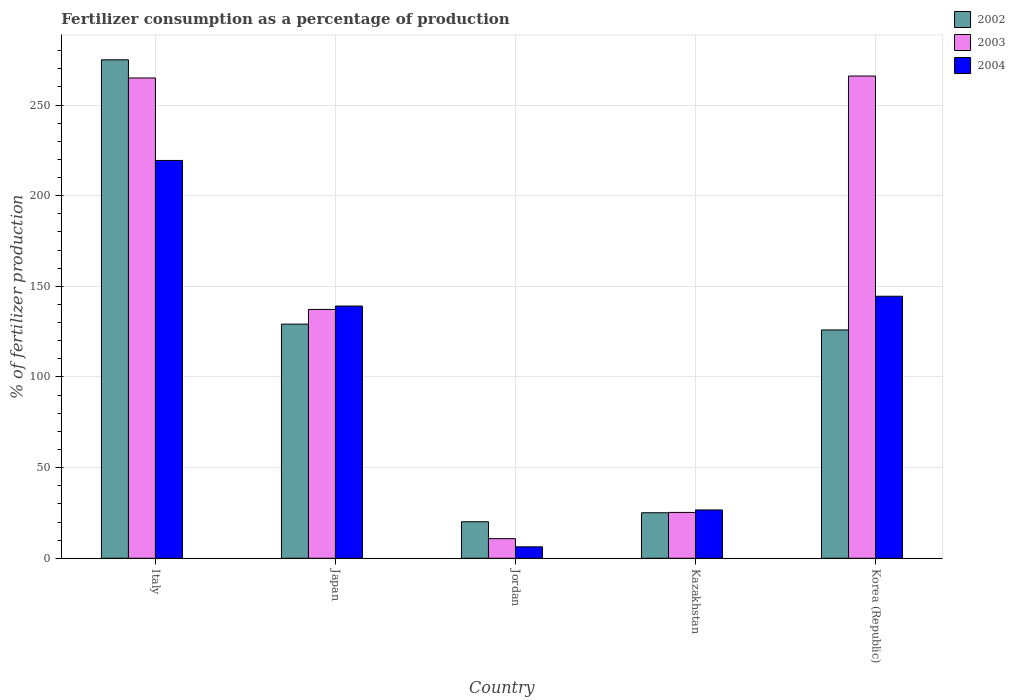Are the number of bars per tick equal to the number of legend labels?
Offer a terse response. Yes. Are the number of bars on each tick of the X-axis equal?
Your response must be concise. Yes. What is the label of the 3rd group of bars from the left?
Offer a very short reply. Jordan. What is the percentage of fertilizers consumed in 2004 in Korea (Republic)?
Your response must be concise. 144.54. Across all countries, what is the maximum percentage of fertilizers consumed in 2004?
Your response must be concise. 219.45. Across all countries, what is the minimum percentage of fertilizers consumed in 2003?
Offer a very short reply. 10.83. In which country was the percentage of fertilizers consumed in 2004 maximum?
Make the answer very short. Italy. In which country was the percentage of fertilizers consumed in 2004 minimum?
Provide a succinct answer. Jordan. What is the total percentage of fertilizers consumed in 2004 in the graph?
Give a very brief answer. 536.07. What is the difference between the percentage of fertilizers consumed in 2002 in Japan and that in Jordan?
Provide a succinct answer. 109.02. What is the difference between the percentage of fertilizers consumed in 2004 in Italy and the percentage of fertilizers consumed in 2002 in Jordan?
Offer a very short reply. 199.3. What is the average percentage of fertilizers consumed in 2003 per country?
Give a very brief answer. 140.87. What is the difference between the percentage of fertilizers consumed of/in 2004 and percentage of fertilizers consumed of/in 2002 in Korea (Republic)?
Your answer should be very brief. 18.59. In how many countries, is the percentage of fertilizers consumed in 2002 greater than 180 %?
Your answer should be compact. 1. What is the ratio of the percentage of fertilizers consumed in 2002 in Italy to that in Korea (Republic)?
Keep it short and to the point. 2.18. Is the difference between the percentage of fertilizers consumed in 2004 in Kazakhstan and Korea (Republic) greater than the difference between the percentage of fertilizers consumed in 2002 in Kazakhstan and Korea (Republic)?
Give a very brief answer. No. What is the difference between the highest and the second highest percentage of fertilizers consumed in 2002?
Keep it short and to the point. -145.81. What is the difference between the highest and the lowest percentage of fertilizers consumed in 2004?
Your response must be concise. 213.14. Is the sum of the percentage of fertilizers consumed in 2004 in Jordan and Korea (Republic) greater than the maximum percentage of fertilizers consumed in 2002 across all countries?
Make the answer very short. No. What does the 1st bar from the left in Korea (Republic) represents?
Make the answer very short. 2002. What does the 1st bar from the right in Korea (Republic) represents?
Ensure brevity in your answer.  2004. How many bars are there?
Offer a very short reply. 15. Are all the bars in the graph horizontal?
Give a very brief answer. No. How many countries are there in the graph?
Ensure brevity in your answer.  5. Are the values on the major ticks of Y-axis written in scientific E-notation?
Offer a very short reply. No. How many legend labels are there?
Give a very brief answer. 3. How are the legend labels stacked?
Offer a terse response. Vertical. What is the title of the graph?
Keep it short and to the point. Fertilizer consumption as a percentage of production. What is the label or title of the Y-axis?
Offer a terse response. % of fertilizer production. What is the % of fertilizer production of 2002 in Italy?
Provide a succinct answer. 274.97. What is the % of fertilizer production of 2003 in Italy?
Your answer should be very brief. 264.94. What is the % of fertilizer production in 2004 in Italy?
Keep it short and to the point. 219.45. What is the % of fertilizer production of 2002 in Japan?
Offer a very short reply. 129.16. What is the % of fertilizer production of 2003 in Japan?
Offer a very short reply. 137.27. What is the % of fertilizer production in 2004 in Japan?
Make the answer very short. 139.13. What is the % of fertilizer production of 2002 in Jordan?
Give a very brief answer. 20.14. What is the % of fertilizer production in 2003 in Jordan?
Provide a succinct answer. 10.83. What is the % of fertilizer production of 2004 in Jordan?
Your response must be concise. 6.31. What is the % of fertilizer production in 2002 in Kazakhstan?
Your answer should be compact. 25.11. What is the % of fertilizer production in 2003 in Kazakhstan?
Give a very brief answer. 25.3. What is the % of fertilizer production in 2004 in Kazakhstan?
Offer a terse response. 26.65. What is the % of fertilizer production of 2002 in Korea (Republic)?
Your answer should be very brief. 125.95. What is the % of fertilizer production in 2003 in Korea (Republic)?
Your answer should be compact. 266.02. What is the % of fertilizer production in 2004 in Korea (Republic)?
Give a very brief answer. 144.54. Across all countries, what is the maximum % of fertilizer production in 2002?
Provide a succinct answer. 274.97. Across all countries, what is the maximum % of fertilizer production of 2003?
Your response must be concise. 266.02. Across all countries, what is the maximum % of fertilizer production in 2004?
Your response must be concise. 219.45. Across all countries, what is the minimum % of fertilizer production in 2002?
Make the answer very short. 20.14. Across all countries, what is the minimum % of fertilizer production of 2003?
Offer a terse response. 10.83. Across all countries, what is the minimum % of fertilizer production of 2004?
Keep it short and to the point. 6.31. What is the total % of fertilizer production of 2002 in the graph?
Your response must be concise. 575.33. What is the total % of fertilizer production of 2003 in the graph?
Provide a succinct answer. 704.36. What is the total % of fertilizer production of 2004 in the graph?
Offer a terse response. 536.07. What is the difference between the % of fertilizer production of 2002 in Italy and that in Japan?
Ensure brevity in your answer.  145.81. What is the difference between the % of fertilizer production of 2003 in Italy and that in Japan?
Offer a very short reply. 127.67. What is the difference between the % of fertilizer production of 2004 in Italy and that in Japan?
Give a very brief answer. 80.32. What is the difference between the % of fertilizer production of 2002 in Italy and that in Jordan?
Keep it short and to the point. 254.83. What is the difference between the % of fertilizer production in 2003 in Italy and that in Jordan?
Ensure brevity in your answer.  254.12. What is the difference between the % of fertilizer production in 2004 in Italy and that in Jordan?
Your answer should be very brief. 213.14. What is the difference between the % of fertilizer production of 2002 in Italy and that in Kazakhstan?
Ensure brevity in your answer.  249.86. What is the difference between the % of fertilizer production of 2003 in Italy and that in Kazakhstan?
Keep it short and to the point. 239.64. What is the difference between the % of fertilizer production of 2004 in Italy and that in Kazakhstan?
Offer a terse response. 192.8. What is the difference between the % of fertilizer production in 2002 in Italy and that in Korea (Republic)?
Offer a terse response. 149.02. What is the difference between the % of fertilizer production in 2003 in Italy and that in Korea (Republic)?
Make the answer very short. -1.08. What is the difference between the % of fertilizer production of 2004 in Italy and that in Korea (Republic)?
Your answer should be compact. 74.91. What is the difference between the % of fertilizer production in 2002 in Japan and that in Jordan?
Give a very brief answer. 109.02. What is the difference between the % of fertilizer production in 2003 in Japan and that in Jordan?
Give a very brief answer. 126.44. What is the difference between the % of fertilizer production of 2004 in Japan and that in Jordan?
Give a very brief answer. 132.82. What is the difference between the % of fertilizer production in 2002 in Japan and that in Kazakhstan?
Make the answer very short. 104.05. What is the difference between the % of fertilizer production in 2003 in Japan and that in Kazakhstan?
Your answer should be compact. 111.97. What is the difference between the % of fertilizer production in 2004 in Japan and that in Kazakhstan?
Keep it short and to the point. 112.49. What is the difference between the % of fertilizer production in 2002 in Japan and that in Korea (Republic)?
Offer a very short reply. 3.21. What is the difference between the % of fertilizer production in 2003 in Japan and that in Korea (Republic)?
Offer a terse response. -128.76. What is the difference between the % of fertilizer production of 2004 in Japan and that in Korea (Republic)?
Your answer should be compact. -5.41. What is the difference between the % of fertilizer production in 2002 in Jordan and that in Kazakhstan?
Keep it short and to the point. -4.96. What is the difference between the % of fertilizer production of 2003 in Jordan and that in Kazakhstan?
Make the answer very short. -14.47. What is the difference between the % of fertilizer production of 2004 in Jordan and that in Kazakhstan?
Your response must be concise. -20.34. What is the difference between the % of fertilizer production of 2002 in Jordan and that in Korea (Republic)?
Offer a terse response. -105.81. What is the difference between the % of fertilizer production in 2003 in Jordan and that in Korea (Republic)?
Your answer should be compact. -255.2. What is the difference between the % of fertilizer production in 2004 in Jordan and that in Korea (Republic)?
Provide a short and direct response. -138.23. What is the difference between the % of fertilizer production of 2002 in Kazakhstan and that in Korea (Republic)?
Give a very brief answer. -100.84. What is the difference between the % of fertilizer production of 2003 in Kazakhstan and that in Korea (Republic)?
Offer a terse response. -240.72. What is the difference between the % of fertilizer production in 2004 in Kazakhstan and that in Korea (Republic)?
Ensure brevity in your answer.  -117.89. What is the difference between the % of fertilizer production in 2002 in Italy and the % of fertilizer production in 2003 in Japan?
Offer a terse response. 137.7. What is the difference between the % of fertilizer production of 2002 in Italy and the % of fertilizer production of 2004 in Japan?
Offer a terse response. 135.84. What is the difference between the % of fertilizer production of 2003 in Italy and the % of fertilizer production of 2004 in Japan?
Provide a short and direct response. 125.81. What is the difference between the % of fertilizer production in 2002 in Italy and the % of fertilizer production in 2003 in Jordan?
Provide a succinct answer. 264.14. What is the difference between the % of fertilizer production in 2002 in Italy and the % of fertilizer production in 2004 in Jordan?
Provide a short and direct response. 268.66. What is the difference between the % of fertilizer production in 2003 in Italy and the % of fertilizer production in 2004 in Jordan?
Offer a terse response. 258.63. What is the difference between the % of fertilizer production in 2002 in Italy and the % of fertilizer production in 2003 in Kazakhstan?
Make the answer very short. 249.67. What is the difference between the % of fertilizer production of 2002 in Italy and the % of fertilizer production of 2004 in Kazakhstan?
Ensure brevity in your answer.  248.32. What is the difference between the % of fertilizer production in 2003 in Italy and the % of fertilizer production in 2004 in Kazakhstan?
Your answer should be very brief. 238.3. What is the difference between the % of fertilizer production of 2002 in Italy and the % of fertilizer production of 2003 in Korea (Republic)?
Ensure brevity in your answer.  8.95. What is the difference between the % of fertilizer production of 2002 in Italy and the % of fertilizer production of 2004 in Korea (Republic)?
Offer a very short reply. 130.43. What is the difference between the % of fertilizer production in 2003 in Italy and the % of fertilizer production in 2004 in Korea (Republic)?
Make the answer very short. 120.4. What is the difference between the % of fertilizer production in 2002 in Japan and the % of fertilizer production in 2003 in Jordan?
Your answer should be very brief. 118.33. What is the difference between the % of fertilizer production in 2002 in Japan and the % of fertilizer production in 2004 in Jordan?
Your answer should be compact. 122.85. What is the difference between the % of fertilizer production in 2003 in Japan and the % of fertilizer production in 2004 in Jordan?
Provide a short and direct response. 130.96. What is the difference between the % of fertilizer production of 2002 in Japan and the % of fertilizer production of 2003 in Kazakhstan?
Give a very brief answer. 103.86. What is the difference between the % of fertilizer production in 2002 in Japan and the % of fertilizer production in 2004 in Kazakhstan?
Give a very brief answer. 102.51. What is the difference between the % of fertilizer production of 2003 in Japan and the % of fertilizer production of 2004 in Kazakhstan?
Offer a terse response. 110.62. What is the difference between the % of fertilizer production of 2002 in Japan and the % of fertilizer production of 2003 in Korea (Republic)?
Give a very brief answer. -136.86. What is the difference between the % of fertilizer production of 2002 in Japan and the % of fertilizer production of 2004 in Korea (Republic)?
Your answer should be compact. -15.38. What is the difference between the % of fertilizer production of 2003 in Japan and the % of fertilizer production of 2004 in Korea (Republic)?
Make the answer very short. -7.27. What is the difference between the % of fertilizer production in 2002 in Jordan and the % of fertilizer production in 2003 in Kazakhstan?
Offer a terse response. -5.16. What is the difference between the % of fertilizer production of 2002 in Jordan and the % of fertilizer production of 2004 in Kazakhstan?
Keep it short and to the point. -6.5. What is the difference between the % of fertilizer production in 2003 in Jordan and the % of fertilizer production in 2004 in Kazakhstan?
Ensure brevity in your answer.  -15.82. What is the difference between the % of fertilizer production in 2002 in Jordan and the % of fertilizer production in 2003 in Korea (Republic)?
Your answer should be very brief. -245.88. What is the difference between the % of fertilizer production in 2002 in Jordan and the % of fertilizer production in 2004 in Korea (Republic)?
Provide a short and direct response. -124.39. What is the difference between the % of fertilizer production in 2003 in Jordan and the % of fertilizer production in 2004 in Korea (Republic)?
Give a very brief answer. -133.71. What is the difference between the % of fertilizer production of 2002 in Kazakhstan and the % of fertilizer production of 2003 in Korea (Republic)?
Your response must be concise. -240.92. What is the difference between the % of fertilizer production in 2002 in Kazakhstan and the % of fertilizer production in 2004 in Korea (Republic)?
Offer a terse response. -119.43. What is the difference between the % of fertilizer production in 2003 in Kazakhstan and the % of fertilizer production in 2004 in Korea (Republic)?
Offer a terse response. -119.24. What is the average % of fertilizer production of 2002 per country?
Provide a short and direct response. 115.07. What is the average % of fertilizer production of 2003 per country?
Offer a terse response. 140.87. What is the average % of fertilizer production of 2004 per country?
Give a very brief answer. 107.21. What is the difference between the % of fertilizer production in 2002 and % of fertilizer production in 2003 in Italy?
Ensure brevity in your answer.  10.03. What is the difference between the % of fertilizer production in 2002 and % of fertilizer production in 2004 in Italy?
Offer a terse response. 55.52. What is the difference between the % of fertilizer production in 2003 and % of fertilizer production in 2004 in Italy?
Your answer should be compact. 45.5. What is the difference between the % of fertilizer production of 2002 and % of fertilizer production of 2003 in Japan?
Make the answer very short. -8.11. What is the difference between the % of fertilizer production in 2002 and % of fertilizer production in 2004 in Japan?
Provide a succinct answer. -9.97. What is the difference between the % of fertilizer production of 2003 and % of fertilizer production of 2004 in Japan?
Your answer should be compact. -1.86. What is the difference between the % of fertilizer production in 2002 and % of fertilizer production in 2003 in Jordan?
Provide a short and direct response. 9.32. What is the difference between the % of fertilizer production of 2002 and % of fertilizer production of 2004 in Jordan?
Ensure brevity in your answer.  13.83. What is the difference between the % of fertilizer production of 2003 and % of fertilizer production of 2004 in Jordan?
Make the answer very short. 4.52. What is the difference between the % of fertilizer production in 2002 and % of fertilizer production in 2003 in Kazakhstan?
Provide a short and direct response. -0.19. What is the difference between the % of fertilizer production in 2002 and % of fertilizer production in 2004 in Kazakhstan?
Provide a succinct answer. -1.54. What is the difference between the % of fertilizer production of 2003 and % of fertilizer production of 2004 in Kazakhstan?
Ensure brevity in your answer.  -1.35. What is the difference between the % of fertilizer production of 2002 and % of fertilizer production of 2003 in Korea (Republic)?
Your answer should be very brief. -140.07. What is the difference between the % of fertilizer production in 2002 and % of fertilizer production in 2004 in Korea (Republic)?
Provide a succinct answer. -18.59. What is the difference between the % of fertilizer production in 2003 and % of fertilizer production in 2004 in Korea (Republic)?
Your answer should be very brief. 121.49. What is the ratio of the % of fertilizer production of 2002 in Italy to that in Japan?
Give a very brief answer. 2.13. What is the ratio of the % of fertilizer production in 2003 in Italy to that in Japan?
Offer a very short reply. 1.93. What is the ratio of the % of fertilizer production in 2004 in Italy to that in Japan?
Provide a succinct answer. 1.58. What is the ratio of the % of fertilizer production in 2002 in Italy to that in Jordan?
Provide a succinct answer. 13.65. What is the ratio of the % of fertilizer production in 2003 in Italy to that in Jordan?
Keep it short and to the point. 24.47. What is the ratio of the % of fertilizer production of 2004 in Italy to that in Jordan?
Your answer should be very brief. 34.78. What is the ratio of the % of fertilizer production of 2002 in Italy to that in Kazakhstan?
Keep it short and to the point. 10.95. What is the ratio of the % of fertilizer production in 2003 in Italy to that in Kazakhstan?
Your answer should be very brief. 10.47. What is the ratio of the % of fertilizer production in 2004 in Italy to that in Kazakhstan?
Provide a succinct answer. 8.24. What is the ratio of the % of fertilizer production of 2002 in Italy to that in Korea (Republic)?
Your response must be concise. 2.18. What is the ratio of the % of fertilizer production of 2004 in Italy to that in Korea (Republic)?
Your answer should be compact. 1.52. What is the ratio of the % of fertilizer production in 2002 in Japan to that in Jordan?
Your response must be concise. 6.41. What is the ratio of the % of fertilizer production in 2003 in Japan to that in Jordan?
Offer a very short reply. 12.68. What is the ratio of the % of fertilizer production in 2004 in Japan to that in Jordan?
Provide a succinct answer. 22.05. What is the ratio of the % of fertilizer production of 2002 in Japan to that in Kazakhstan?
Offer a very short reply. 5.14. What is the ratio of the % of fertilizer production of 2003 in Japan to that in Kazakhstan?
Your answer should be very brief. 5.43. What is the ratio of the % of fertilizer production in 2004 in Japan to that in Kazakhstan?
Offer a very short reply. 5.22. What is the ratio of the % of fertilizer production of 2002 in Japan to that in Korea (Republic)?
Your answer should be very brief. 1.03. What is the ratio of the % of fertilizer production in 2003 in Japan to that in Korea (Republic)?
Your answer should be compact. 0.52. What is the ratio of the % of fertilizer production in 2004 in Japan to that in Korea (Republic)?
Offer a very short reply. 0.96. What is the ratio of the % of fertilizer production in 2002 in Jordan to that in Kazakhstan?
Give a very brief answer. 0.8. What is the ratio of the % of fertilizer production in 2003 in Jordan to that in Kazakhstan?
Provide a succinct answer. 0.43. What is the ratio of the % of fertilizer production in 2004 in Jordan to that in Kazakhstan?
Your answer should be very brief. 0.24. What is the ratio of the % of fertilizer production in 2002 in Jordan to that in Korea (Republic)?
Your response must be concise. 0.16. What is the ratio of the % of fertilizer production in 2003 in Jordan to that in Korea (Republic)?
Keep it short and to the point. 0.04. What is the ratio of the % of fertilizer production in 2004 in Jordan to that in Korea (Republic)?
Make the answer very short. 0.04. What is the ratio of the % of fertilizer production in 2002 in Kazakhstan to that in Korea (Republic)?
Provide a succinct answer. 0.2. What is the ratio of the % of fertilizer production of 2003 in Kazakhstan to that in Korea (Republic)?
Make the answer very short. 0.1. What is the ratio of the % of fertilizer production in 2004 in Kazakhstan to that in Korea (Republic)?
Make the answer very short. 0.18. What is the difference between the highest and the second highest % of fertilizer production in 2002?
Ensure brevity in your answer.  145.81. What is the difference between the highest and the second highest % of fertilizer production of 2003?
Offer a very short reply. 1.08. What is the difference between the highest and the second highest % of fertilizer production of 2004?
Ensure brevity in your answer.  74.91. What is the difference between the highest and the lowest % of fertilizer production in 2002?
Provide a short and direct response. 254.83. What is the difference between the highest and the lowest % of fertilizer production in 2003?
Make the answer very short. 255.2. What is the difference between the highest and the lowest % of fertilizer production of 2004?
Make the answer very short. 213.14. 